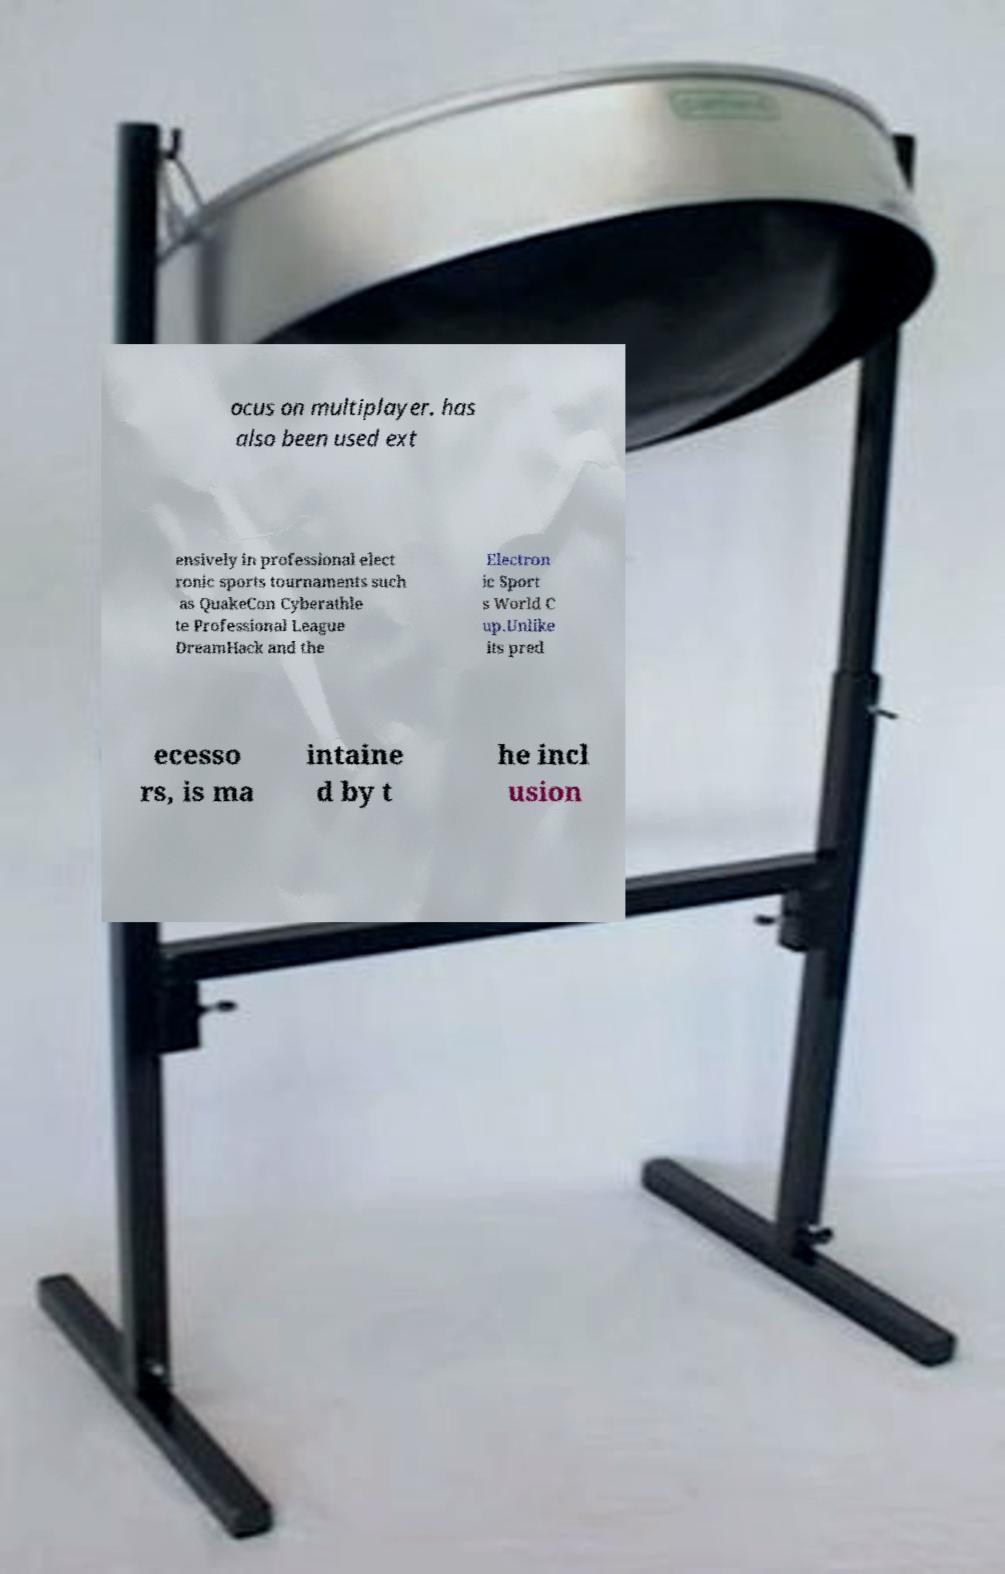For documentation purposes, I need the text within this image transcribed. Could you provide that? ocus on multiplayer. has also been used ext ensively in professional elect ronic sports tournaments such as QuakeCon Cyberathle te Professional League DreamHack and the Electron ic Sport s World C up.Unlike its pred ecesso rs, is ma intaine d by t he incl usion 